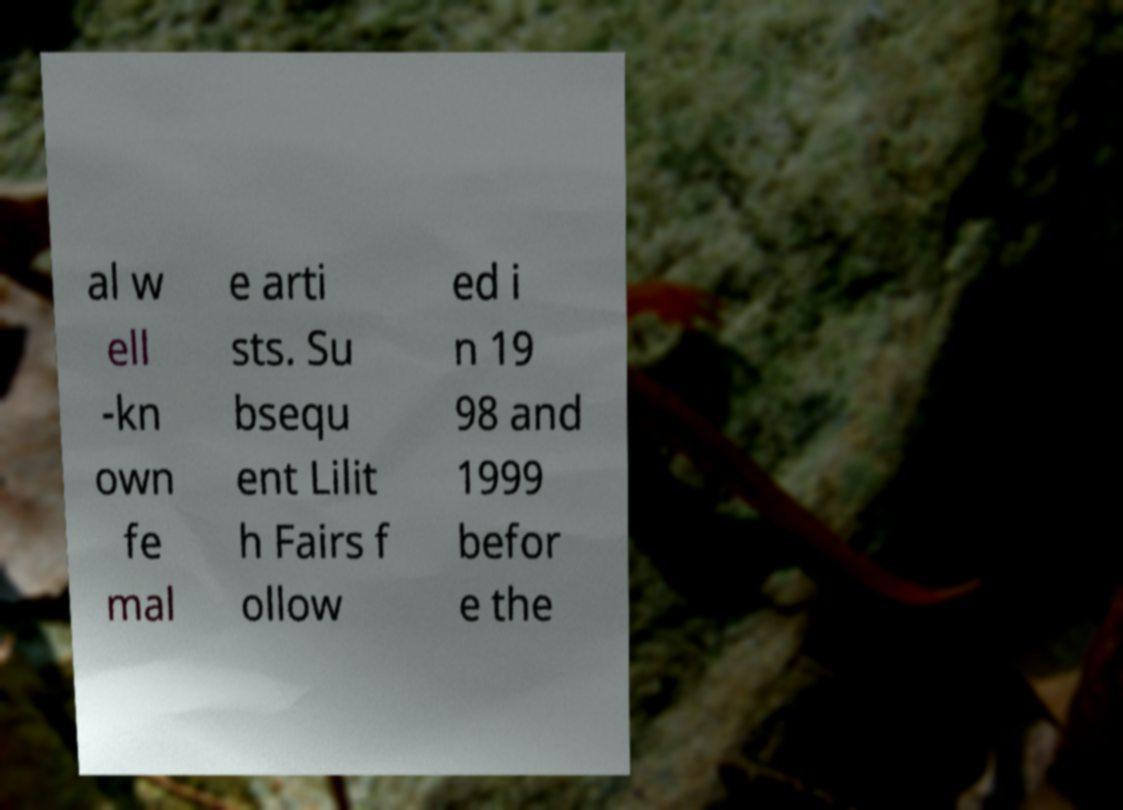Please identify and transcribe the text found in this image. al w ell -kn own fe mal e arti sts. Su bsequ ent Lilit h Fairs f ollow ed i n 19 98 and 1999 befor e the 